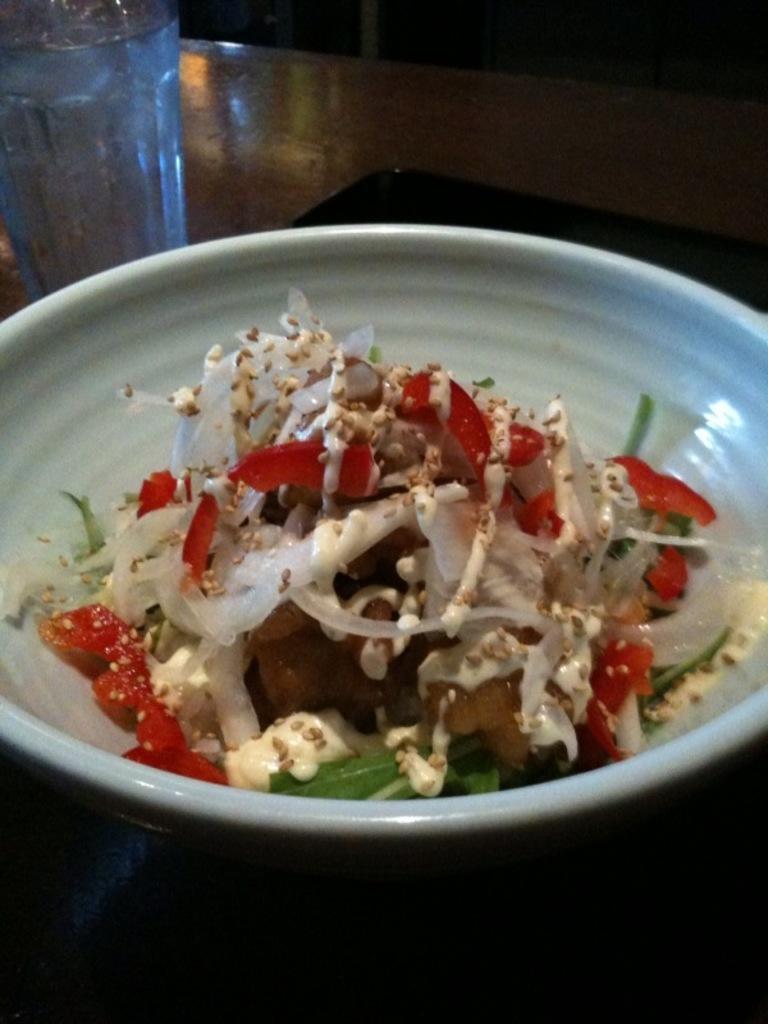Please provide a concise description of this image. In this image there is a food in a bowl and a glass of water arranged on the table. 